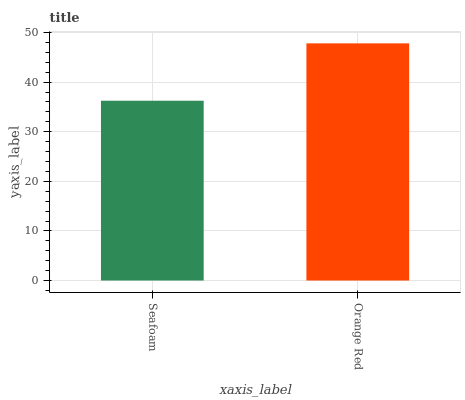Is Seafoam the minimum?
Answer yes or no. Yes. Is Orange Red the maximum?
Answer yes or no. Yes. Is Orange Red the minimum?
Answer yes or no. No. Is Orange Red greater than Seafoam?
Answer yes or no. Yes. Is Seafoam less than Orange Red?
Answer yes or no. Yes. Is Seafoam greater than Orange Red?
Answer yes or no. No. Is Orange Red less than Seafoam?
Answer yes or no. No. Is Orange Red the high median?
Answer yes or no. Yes. Is Seafoam the low median?
Answer yes or no. Yes. Is Seafoam the high median?
Answer yes or no. No. Is Orange Red the low median?
Answer yes or no. No. 